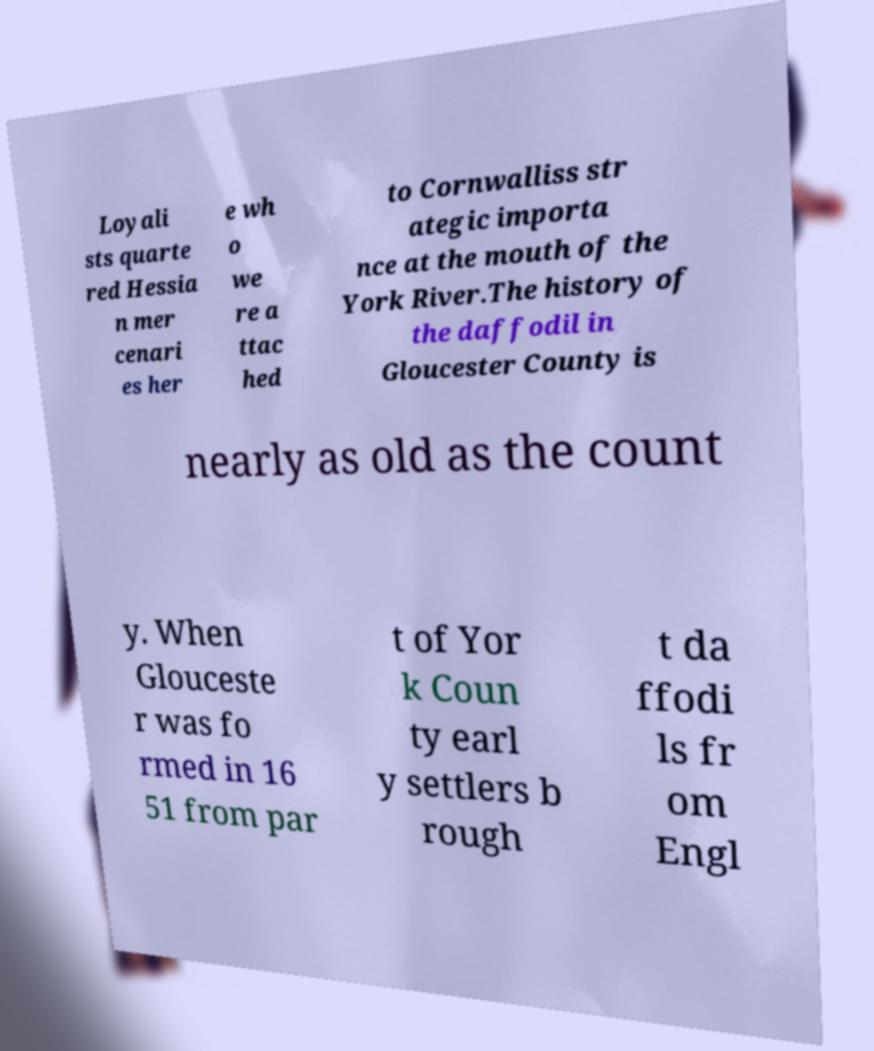Can you accurately transcribe the text from the provided image for me? Loyali sts quarte red Hessia n mer cenari es her e wh o we re a ttac hed to Cornwalliss str ategic importa nce at the mouth of the York River.The history of the daffodil in Gloucester County is nearly as old as the count y. When Glouceste r was fo rmed in 16 51 from par t of Yor k Coun ty earl y settlers b rough t da ffodi ls fr om Engl 